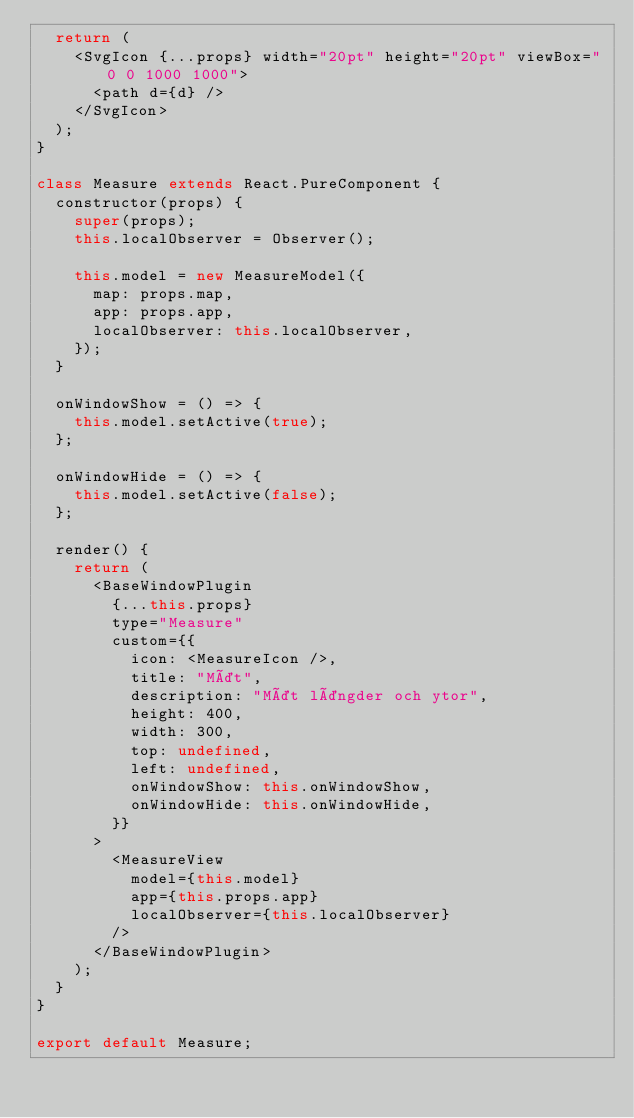Convert code to text. <code><loc_0><loc_0><loc_500><loc_500><_JavaScript_>  return (
    <SvgIcon {...props} width="20pt" height="20pt" viewBox="0 0 1000 1000">
      <path d={d} />
    </SvgIcon>
  );
}

class Measure extends React.PureComponent {
  constructor(props) {
    super(props);
    this.localObserver = Observer();

    this.model = new MeasureModel({
      map: props.map,
      app: props.app,
      localObserver: this.localObserver,
    });
  }

  onWindowShow = () => {
    this.model.setActive(true);
  };

  onWindowHide = () => {
    this.model.setActive(false);
  };

  render() {
    return (
      <BaseWindowPlugin
        {...this.props}
        type="Measure"
        custom={{
          icon: <MeasureIcon />,
          title: "Mät",
          description: "Mät längder och ytor",
          height: 400,
          width: 300,
          top: undefined,
          left: undefined,
          onWindowShow: this.onWindowShow,
          onWindowHide: this.onWindowHide,
        }}
      >
        <MeasureView
          model={this.model}
          app={this.props.app}
          localObserver={this.localObserver}
        />
      </BaseWindowPlugin>
    );
  }
}

export default Measure;
</code> 